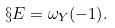<formula> <loc_0><loc_0><loc_500><loc_500>\S E = \omega _ { Y } ( - 1 ) .</formula> 